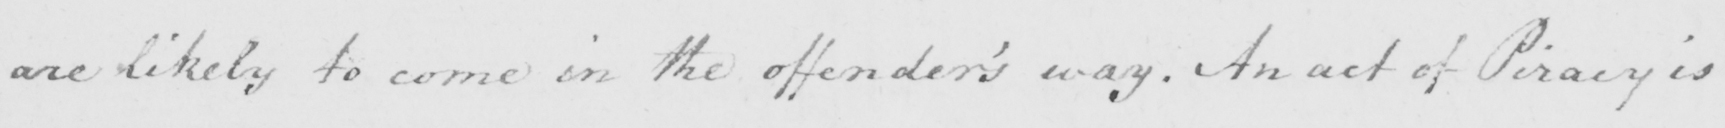Please transcribe the handwritten text in this image. are likely to come in the offender's way. An act of Piracy is 